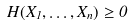Convert formula to latex. <formula><loc_0><loc_0><loc_500><loc_500>H ( X _ { 1 } , \dots , X _ { n } ) \geq 0</formula> 